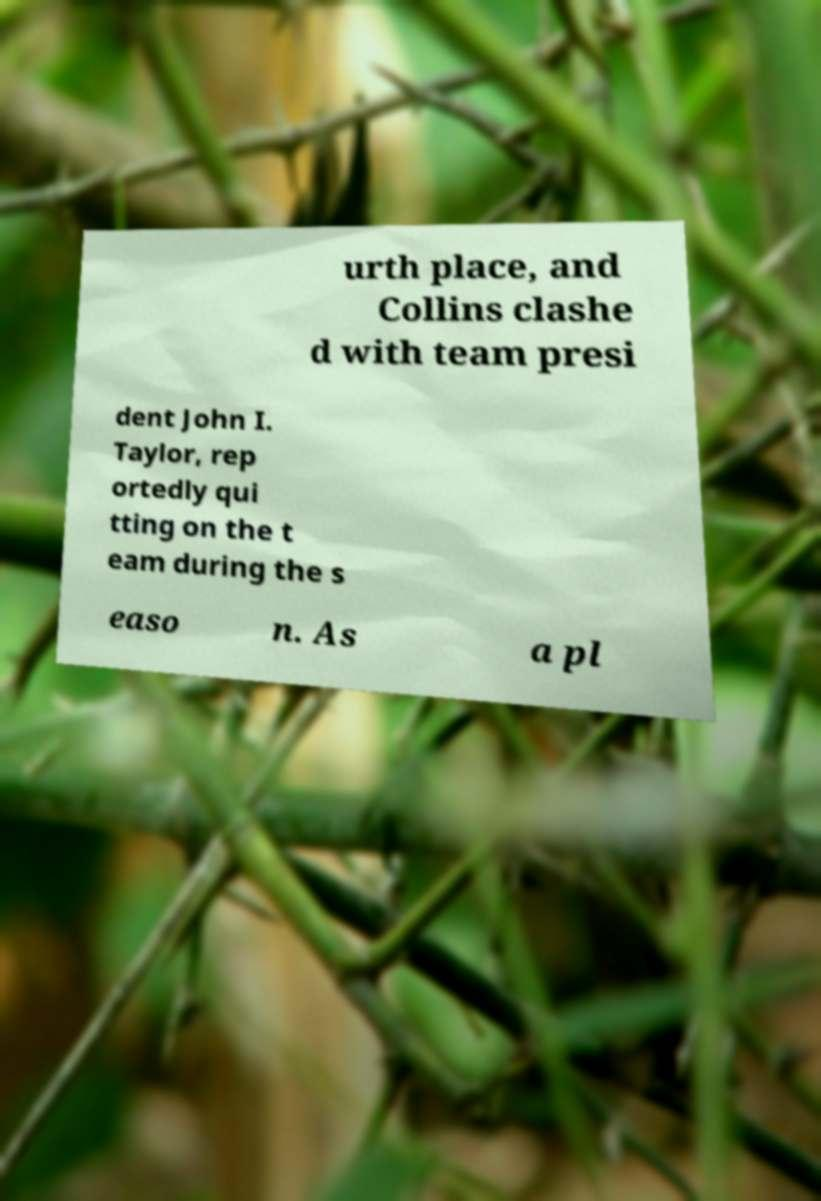Please identify and transcribe the text found in this image. urth place, and Collins clashe d with team presi dent John I. Taylor, rep ortedly qui tting on the t eam during the s easo n. As a pl 